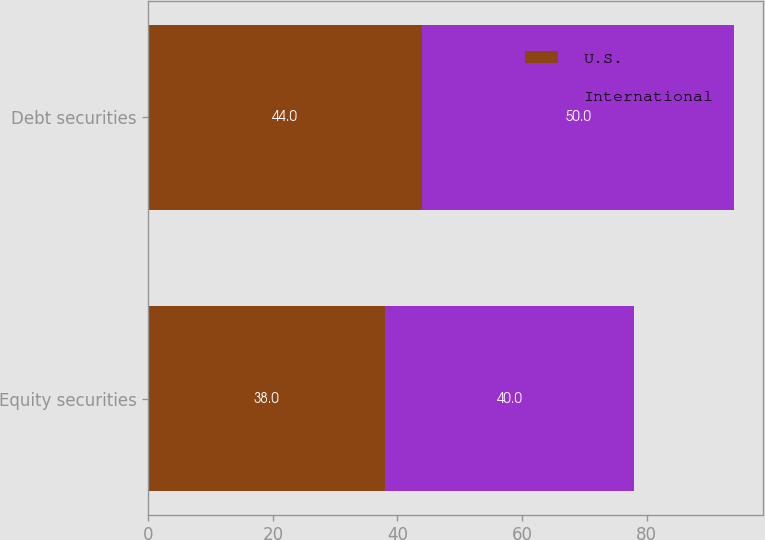Convert chart to OTSL. <chart><loc_0><loc_0><loc_500><loc_500><stacked_bar_chart><ecel><fcel>Equity securities<fcel>Debt securities<nl><fcel>U.S.<fcel>38<fcel>44<nl><fcel>International<fcel>40<fcel>50<nl></chart> 